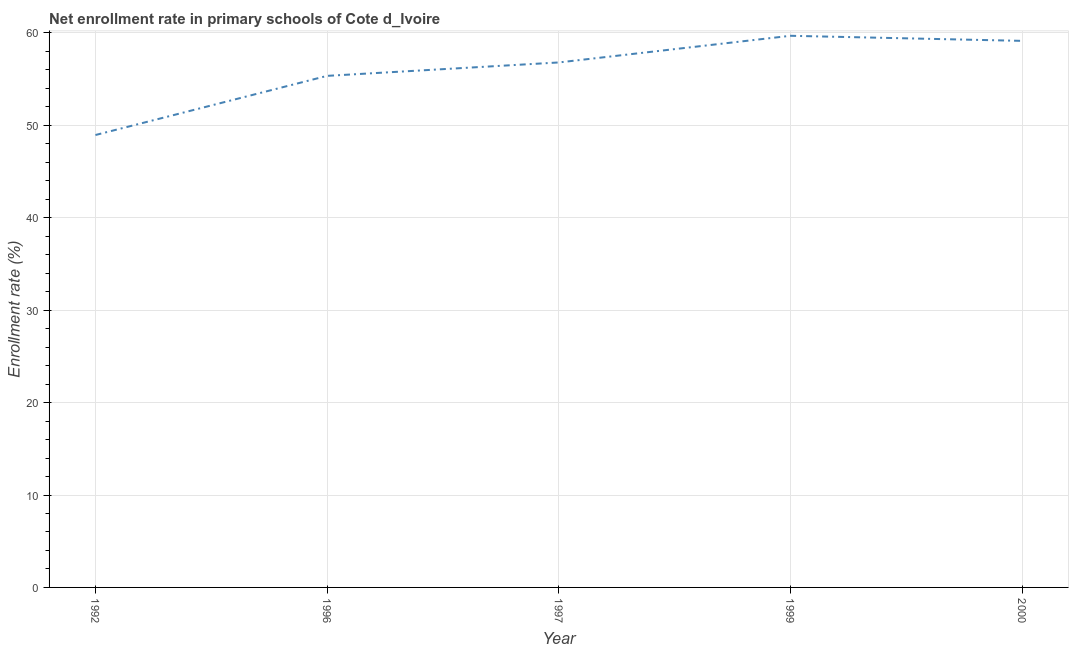What is the net enrollment rate in primary schools in 1992?
Provide a succinct answer. 48.95. Across all years, what is the maximum net enrollment rate in primary schools?
Your answer should be very brief. 59.69. Across all years, what is the minimum net enrollment rate in primary schools?
Keep it short and to the point. 48.95. What is the sum of the net enrollment rate in primary schools?
Make the answer very short. 279.92. What is the difference between the net enrollment rate in primary schools in 1996 and 1999?
Offer a terse response. -4.34. What is the average net enrollment rate in primary schools per year?
Your answer should be very brief. 55.98. What is the median net enrollment rate in primary schools?
Keep it short and to the point. 56.8. What is the ratio of the net enrollment rate in primary schools in 1992 to that in 1996?
Make the answer very short. 0.88. Is the difference between the net enrollment rate in primary schools in 1999 and 2000 greater than the difference between any two years?
Provide a short and direct response. No. What is the difference between the highest and the second highest net enrollment rate in primary schools?
Ensure brevity in your answer.  0.55. What is the difference between the highest and the lowest net enrollment rate in primary schools?
Your response must be concise. 10.74. In how many years, is the net enrollment rate in primary schools greater than the average net enrollment rate in primary schools taken over all years?
Keep it short and to the point. 3. Does the net enrollment rate in primary schools monotonically increase over the years?
Provide a succinct answer. No. Does the graph contain grids?
Your answer should be compact. Yes. What is the title of the graph?
Give a very brief answer. Net enrollment rate in primary schools of Cote d_Ivoire. What is the label or title of the X-axis?
Your answer should be very brief. Year. What is the label or title of the Y-axis?
Give a very brief answer. Enrollment rate (%). What is the Enrollment rate (%) of 1992?
Your answer should be compact. 48.95. What is the Enrollment rate (%) in 1996?
Offer a very short reply. 55.35. What is the Enrollment rate (%) in 1997?
Your answer should be compact. 56.8. What is the Enrollment rate (%) of 1999?
Provide a succinct answer. 59.69. What is the Enrollment rate (%) of 2000?
Provide a succinct answer. 59.14. What is the difference between the Enrollment rate (%) in 1992 and 1996?
Your response must be concise. -6.4. What is the difference between the Enrollment rate (%) in 1992 and 1997?
Ensure brevity in your answer.  -7.85. What is the difference between the Enrollment rate (%) in 1992 and 1999?
Give a very brief answer. -10.74. What is the difference between the Enrollment rate (%) in 1992 and 2000?
Your answer should be very brief. -10.19. What is the difference between the Enrollment rate (%) in 1996 and 1997?
Offer a terse response. -1.45. What is the difference between the Enrollment rate (%) in 1996 and 1999?
Make the answer very short. -4.34. What is the difference between the Enrollment rate (%) in 1996 and 2000?
Your answer should be very brief. -3.79. What is the difference between the Enrollment rate (%) in 1997 and 1999?
Offer a terse response. -2.88. What is the difference between the Enrollment rate (%) in 1997 and 2000?
Offer a very short reply. -2.33. What is the difference between the Enrollment rate (%) in 1999 and 2000?
Give a very brief answer. 0.55. What is the ratio of the Enrollment rate (%) in 1992 to that in 1996?
Your answer should be compact. 0.88. What is the ratio of the Enrollment rate (%) in 1992 to that in 1997?
Offer a terse response. 0.86. What is the ratio of the Enrollment rate (%) in 1992 to that in 1999?
Offer a very short reply. 0.82. What is the ratio of the Enrollment rate (%) in 1992 to that in 2000?
Ensure brevity in your answer.  0.83. What is the ratio of the Enrollment rate (%) in 1996 to that in 1999?
Make the answer very short. 0.93. What is the ratio of the Enrollment rate (%) in 1996 to that in 2000?
Give a very brief answer. 0.94. What is the ratio of the Enrollment rate (%) in 1997 to that in 1999?
Your answer should be very brief. 0.95. What is the ratio of the Enrollment rate (%) in 1999 to that in 2000?
Offer a very short reply. 1.01. 